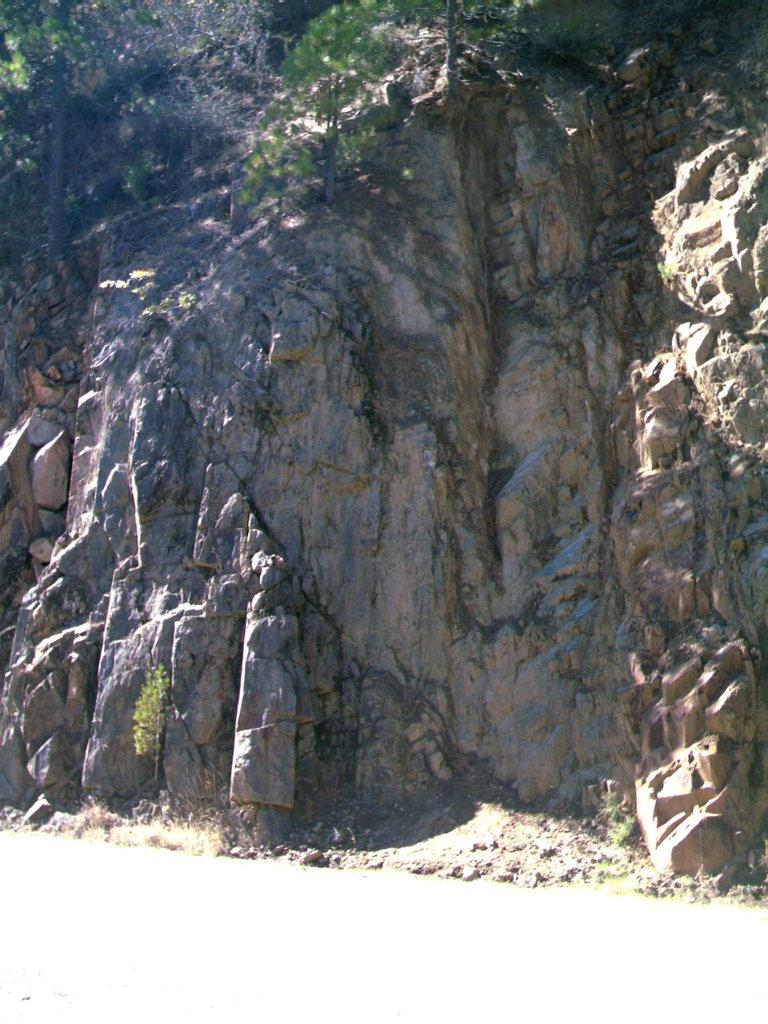Where was the image taken from? The image was taken from the outside of the city. What can be seen in the background of the image? There are rocks, plants, and grass in the background of the image. What color is at the bottom of the image? The bottom of the image has a white color. What type of amusement can be seen at the top of the image? There is no amusement present in the image; it features a view of the natural landscape outside the city. What sign is visible in the image? There is no sign visible in the image. 